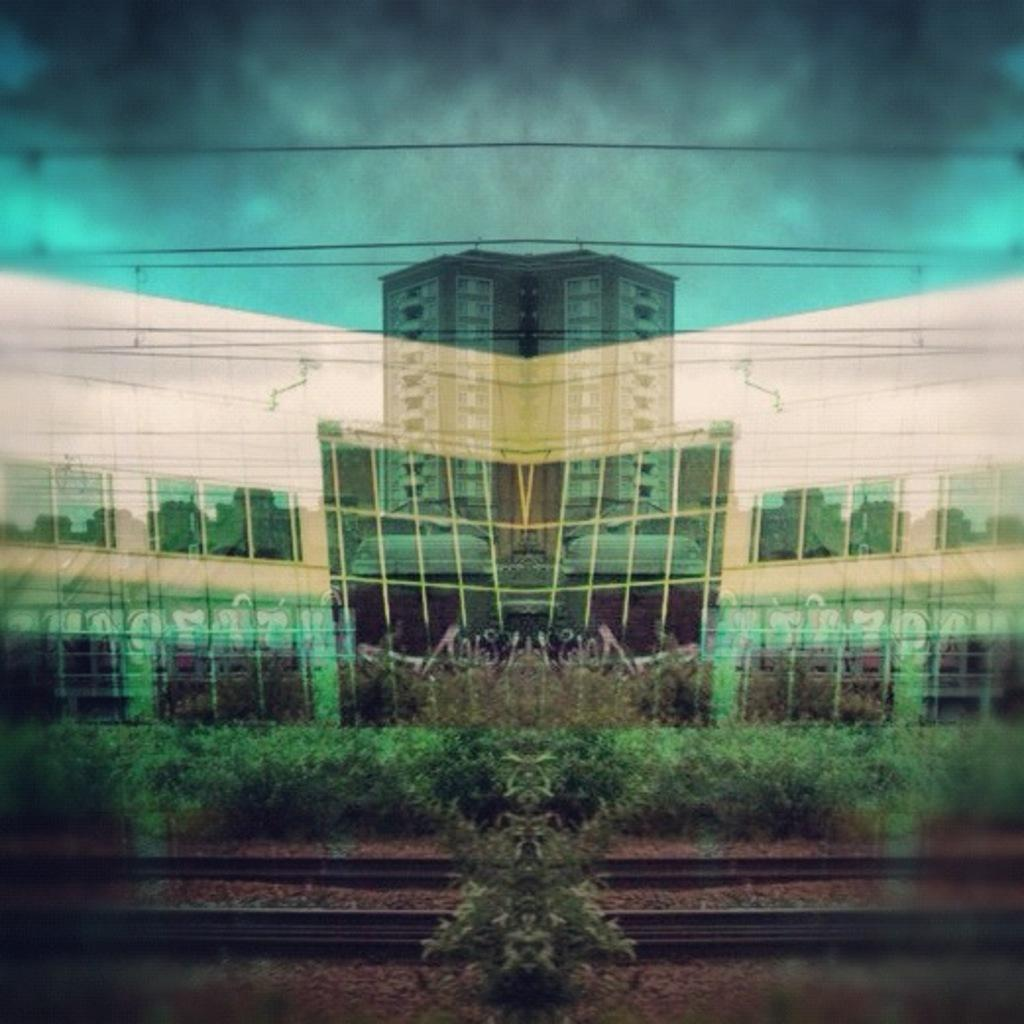What type of structure is present in the image? There is a building in the image. What else can be seen in the image besides the building? There are plants and railway tracks in the image. What part of the natural environment is visible in the image? The sky is visible in the image. How many babies are crawling on the railway tracks in the image? There are no babies present in the image; it only features a building, plants, railway tracks, and the sky. 